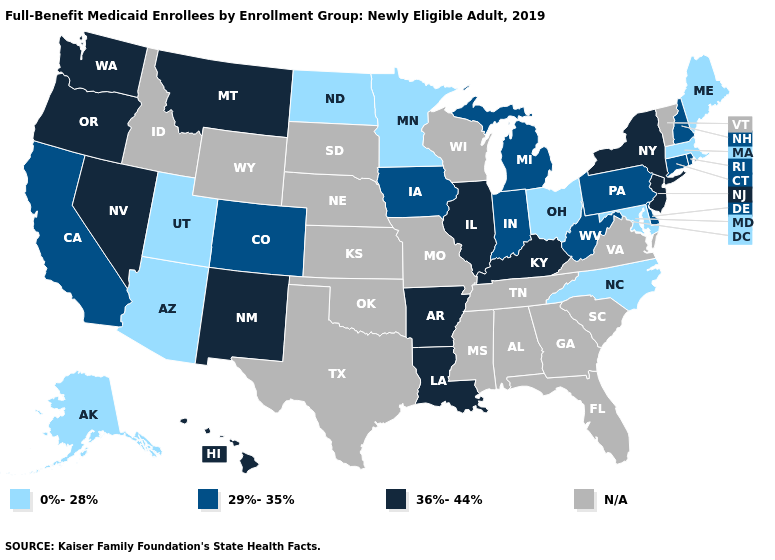Among the states that border California , which have the lowest value?
Write a very short answer. Arizona. Does the first symbol in the legend represent the smallest category?
Write a very short answer. Yes. Does the first symbol in the legend represent the smallest category?
Answer briefly. Yes. Name the states that have a value in the range N/A?
Quick response, please. Alabama, Florida, Georgia, Idaho, Kansas, Mississippi, Missouri, Nebraska, Oklahoma, South Carolina, South Dakota, Tennessee, Texas, Vermont, Virginia, Wisconsin, Wyoming. Does New Mexico have the lowest value in the USA?
Write a very short answer. No. What is the highest value in the USA?
Write a very short answer. 36%-44%. Which states have the lowest value in the USA?
Concise answer only. Alaska, Arizona, Maine, Maryland, Massachusetts, Minnesota, North Carolina, North Dakota, Ohio, Utah. Does Utah have the highest value in the USA?
Concise answer only. No. Does North Dakota have the highest value in the USA?
Concise answer only. No. What is the value of Hawaii?
Keep it brief. 36%-44%. Name the states that have a value in the range N/A?
Answer briefly. Alabama, Florida, Georgia, Idaho, Kansas, Mississippi, Missouri, Nebraska, Oklahoma, South Carolina, South Dakota, Tennessee, Texas, Vermont, Virginia, Wisconsin, Wyoming. Which states have the highest value in the USA?
Write a very short answer. Arkansas, Hawaii, Illinois, Kentucky, Louisiana, Montana, Nevada, New Jersey, New Mexico, New York, Oregon, Washington. What is the value of Kentucky?
Concise answer only. 36%-44%. Which states have the lowest value in the West?
Be succinct. Alaska, Arizona, Utah. 